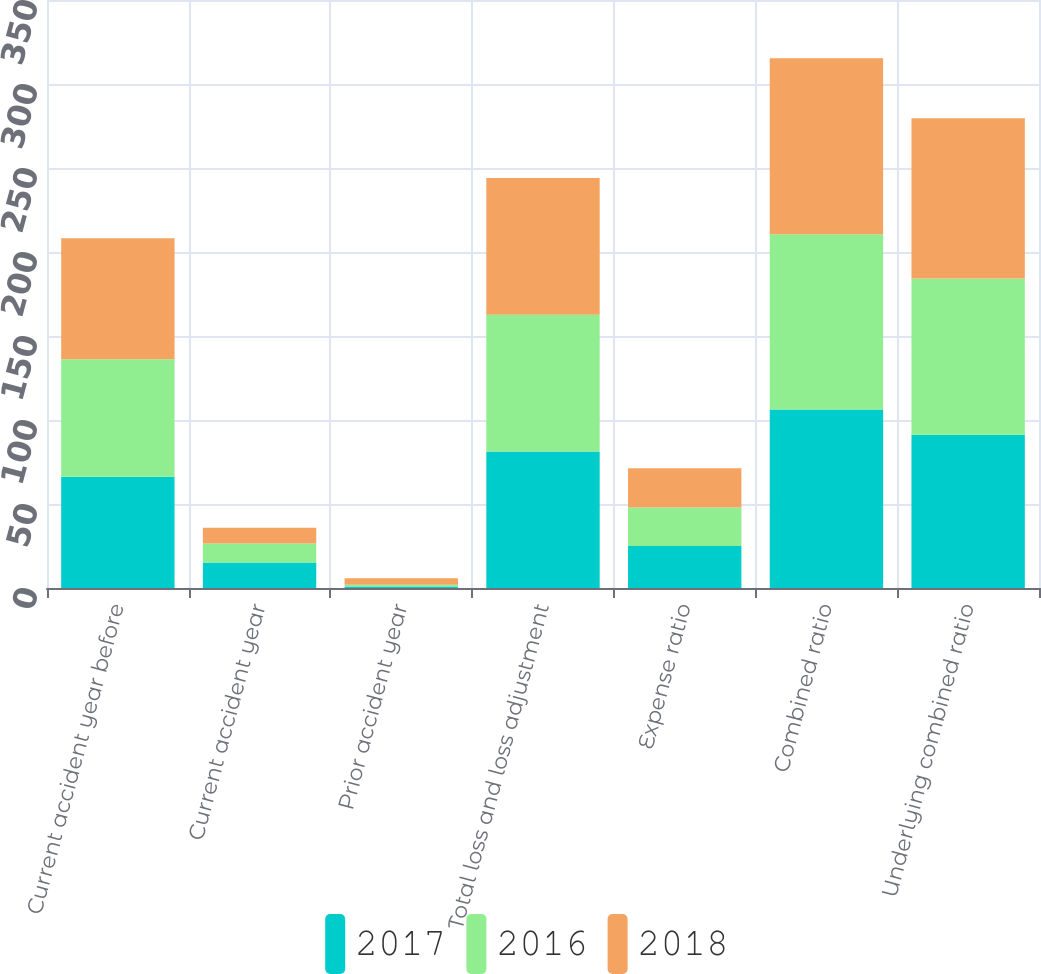Convert chart. <chart><loc_0><loc_0><loc_500><loc_500><stacked_bar_chart><ecel><fcel>Current accident year before<fcel>Current accident year<fcel>Prior accident year<fcel>Total loss and loss adjustment<fcel>Expense ratio<fcel>Combined ratio<fcel>Underlying combined ratio<nl><fcel>2017<fcel>66.2<fcel>15.2<fcel>0.9<fcel>81.3<fcel>25<fcel>106.3<fcel>91.2<nl><fcel>2016<fcel>70<fcel>11.3<fcel>1<fcel>81.3<fcel>22.9<fcel>104.2<fcel>93<nl><fcel>2018<fcel>72<fcel>9.4<fcel>3.9<fcel>81.5<fcel>23.4<fcel>104.8<fcel>95.4<nl></chart> 